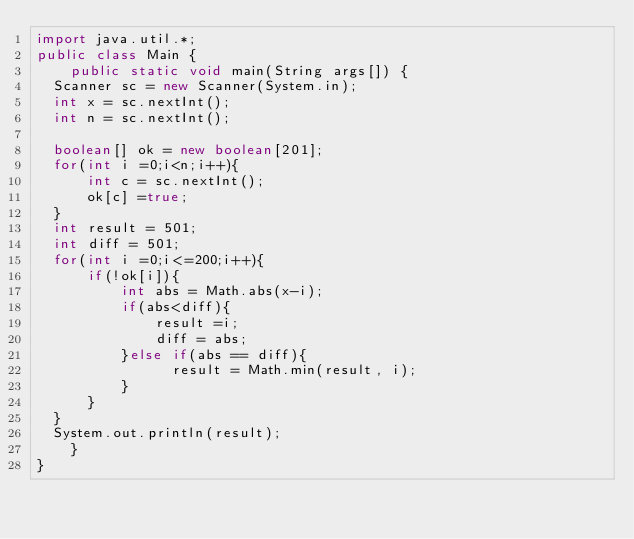Convert code to text. <code><loc_0><loc_0><loc_500><loc_500><_Java_>import java.util.*;
public class Main {
    public static void main(String args[]) {
  Scanner sc = new Scanner(System.in);
  int x = sc.nextInt();
  int n = sc.nextInt();
  
  boolean[] ok = new boolean[201];
  for(int i =0;i<n;i++){
      int c = sc.nextInt();
      ok[c] =true;
  }
  int result = 501;
  int diff = 501;
  for(int i =0;i<=200;i++){
      if(!ok[i]){
          int abs = Math.abs(x-i);
          if(abs<diff){
              result =i;
              diff = abs;
          }else if(abs == diff){
                result = Math.min(result, i);
          }
      }
  }
  System.out.println(result);
    }
}</code> 